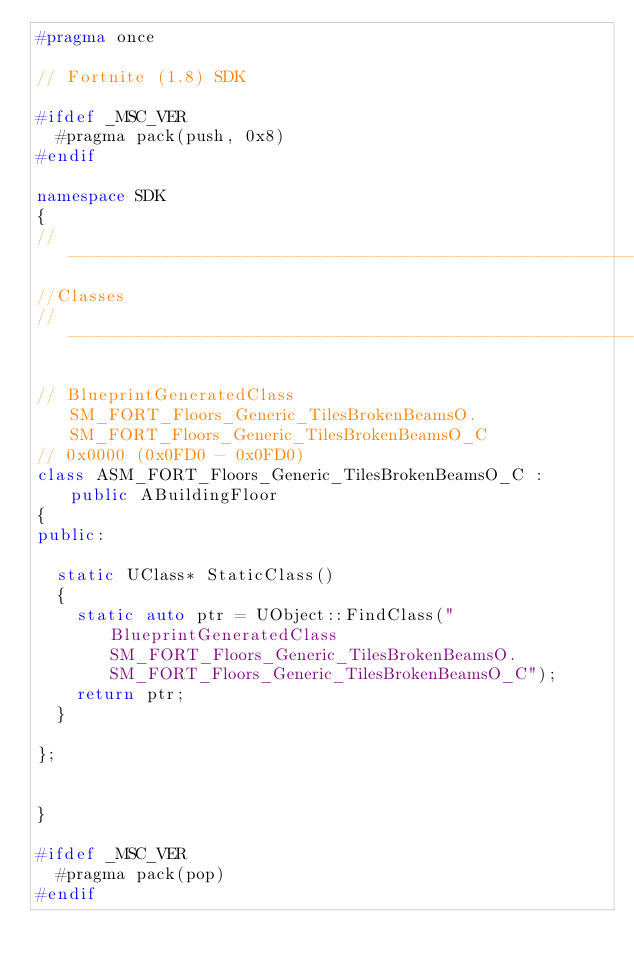<code> <loc_0><loc_0><loc_500><loc_500><_C++_>#pragma once

// Fortnite (1.8) SDK

#ifdef _MSC_VER
	#pragma pack(push, 0x8)
#endif

namespace SDK
{
//---------------------------------------------------------------------------
//Classes
//---------------------------------------------------------------------------

// BlueprintGeneratedClass SM_FORT_Floors_Generic_TilesBrokenBeamsO.SM_FORT_Floors_Generic_TilesBrokenBeamsO_C
// 0x0000 (0x0FD0 - 0x0FD0)
class ASM_FORT_Floors_Generic_TilesBrokenBeamsO_C : public ABuildingFloor
{
public:

	static UClass* StaticClass()
	{
		static auto ptr = UObject::FindClass("BlueprintGeneratedClass SM_FORT_Floors_Generic_TilesBrokenBeamsO.SM_FORT_Floors_Generic_TilesBrokenBeamsO_C");
		return ptr;
	}

};


}

#ifdef _MSC_VER
	#pragma pack(pop)
#endif
</code> 